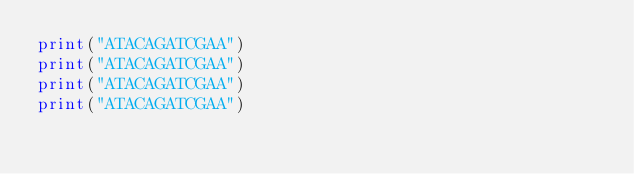Convert code to text. <code><loc_0><loc_0><loc_500><loc_500><_Python_>print("ATACAGATCGAA")
print("ATACAGATCGAA")
print("ATACAGATCGAA")
print("ATACAGATCGAA")
</code> 